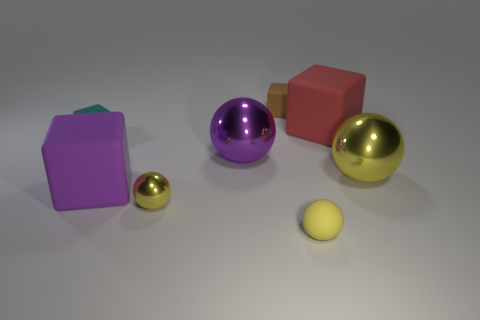Are there fewer tiny gray metal cylinders than small yellow shiny things?
Ensure brevity in your answer.  Yes. There is a purple object that is on the right side of the large purple block; are there any big yellow metallic balls behind it?
Give a very brief answer. No. There is a tiny yellow thing that is the same material as the brown cube; what shape is it?
Offer a very short reply. Sphere. Are there any other things of the same color as the small shiny block?
Give a very brief answer. No. There is a big yellow thing that is the same shape as the large purple shiny thing; what material is it?
Your answer should be compact. Metal. What number of other objects are there of the same size as the purple rubber block?
Make the answer very short. 3. There is a matte sphere that is the same color as the tiny metal ball; what is its size?
Make the answer very short. Small. There is a small matte thing that is in front of the tiny yellow metal ball; is its shape the same as the purple rubber thing?
Your response must be concise. No. What number of other things are the same shape as the red rubber thing?
Provide a short and direct response. 3. What is the shape of the tiny matte object that is in front of the purple block?
Your answer should be very brief. Sphere. 